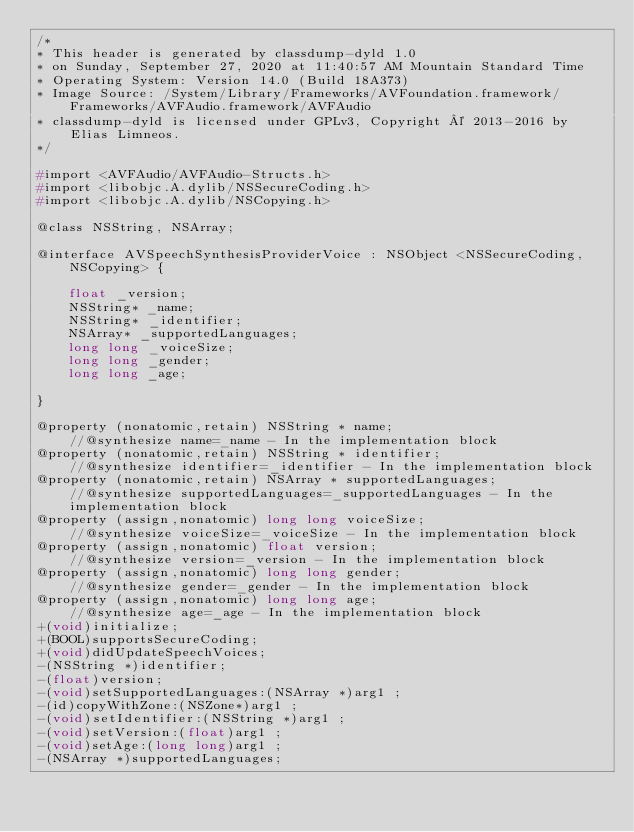Convert code to text. <code><loc_0><loc_0><loc_500><loc_500><_C_>/*
* This header is generated by classdump-dyld 1.0
* on Sunday, September 27, 2020 at 11:40:57 AM Mountain Standard Time
* Operating System: Version 14.0 (Build 18A373)
* Image Source: /System/Library/Frameworks/AVFoundation.framework/Frameworks/AVFAudio.framework/AVFAudio
* classdump-dyld is licensed under GPLv3, Copyright © 2013-2016 by Elias Limneos.
*/

#import <AVFAudio/AVFAudio-Structs.h>
#import <libobjc.A.dylib/NSSecureCoding.h>
#import <libobjc.A.dylib/NSCopying.h>

@class NSString, NSArray;

@interface AVSpeechSynthesisProviderVoice : NSObject <NSSecureCoding, NSCopying> {

	float _version;
	NSString* _name;
	NSString* _identifier;
	NSArray* _supportedLanguages;
	long long _voiceSize;
	long long _gender;
	long long _age;

}

@property (nonatomic,retain) NSString * name;                           //@synthesize name=_name - In the implementation block
@property (nonatomic,retain) NSString * identifier;                     //@synthesize identifier=_identifier - In the implementation block
@property (nonatomic,retain) NSArray * supportedLanguages;              //@synthesize supportedLanguages=_supportedLanguages - In the implementation block
@property (assign,nonatomic) long long voiceSize;                       //@synthesize voiceSize=_voiceSize - In the implementation block
@property (assign,nonatomic) float version;                             //@synthesize version=_version - In the implementation block
@property (assign,nonatomic) long long gender;                          //@synthesize gender=_gender - In the implementation block
@property (assign,nonatomic) long long age;                             //@synthesize age=_age - In the implementation block
+(void)initialize;
+(BOOL)supportsSecureCoding;
+(void)didUpdateSpeechVoices;
-(NSString *)identifier;
-(float)version;
-(void)setSupportedLanguages:(NSArray *)arg1 ;
-(id)copyWithZone:(NSZone*)arg1 ;
-(void)setIdentifier:(NSString *)arg1 ;
-(void)setVersion:(float)arg1 ;
-(void)setAge:(long long)arg1 ;
-(NSArray *)supportedLanguages;</code> 